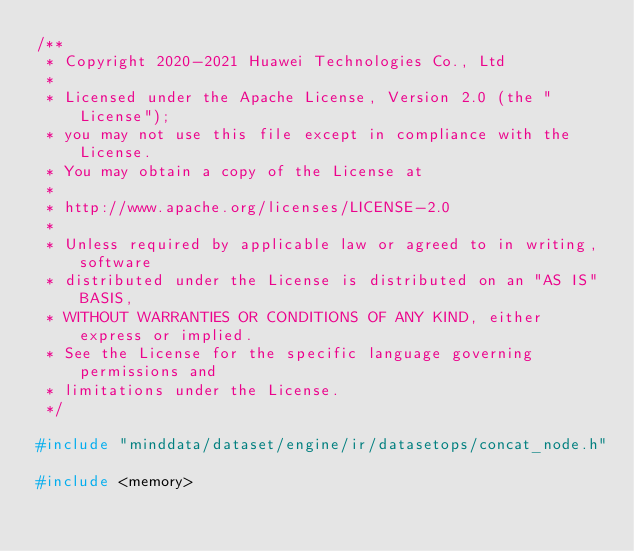Convert code to text. <code><loc_0><loc_0><loc_500><loc_500><_C++_>/**
 * Copyright 2020-2021 Huawei Technologies Co., Ltd
 *
 * Licensed under the Apache License, Version 2.0 (the "License");
 * you may not use this file except in compliance with the License.
 * You may obtain a copy of the License at
 *
 * http://www.apache.org/licenses/LICENSE-2.0
 *
 * Unless required by applicable law or agreed to in writing, software
 * distributed under the License is distributed on an "AS IS" BASIS,
 * WITHOUT WARRANTIES OR CONDITIONS OF ANY KIND, either express or implied.
 * See the License for the specific language governing permissions and
 * limitations under the License.
 */

#include "minddata/dataset/engine/ir/datasetops/concat_node.h"

#include <memory></code> 